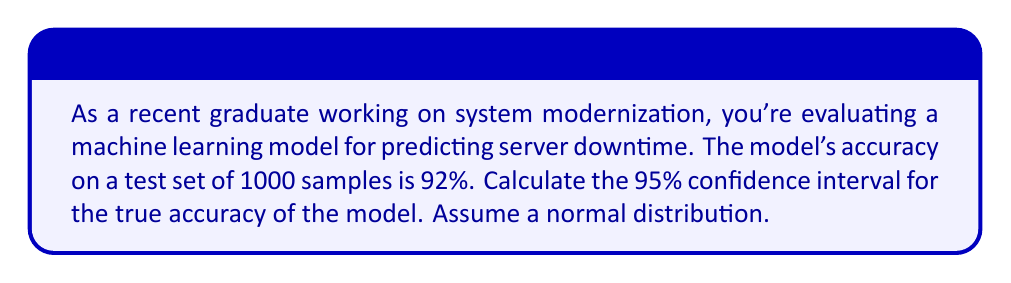Provide a solution to this math problem. Let's approach this step-by-step:

1) First, we need to identify the key components:
   - Sample size (n) = 1000
   - Sample proportion (p) = 0.92 (92% accuracy)
   - Confidence level = 95% (z-score = 1.96)

2) The formula for the confidence interval of a proportion is:

   $$ CI = p \pm z \sqrt{\frac{p(1-p)}{n}} $$

3) Let's calculate the standard error:

   $$ SE = \sqrt{\frac{p(1-p)}{n}} = \sqrt{\frac{0.92(1-0.92)}{1000}} = \sqrt{\frac{0.0736}{1000}} = 0.00857 $$

4) Now, we can calculate the margin of error:

   $$ ME = z \cdot SE = 1.96 \cdot 0.00857 = 0.0168 $$

5) Finally, we can calculate the confidence interval:

   Lower bound: $0.92 - 0.0168 = 0.9032$
   Upper bound: $0.92 + 0.0168 = 0.9368$

6) Converting to percentages:

   The 95% confidence interval is (90.32%, 93.68%)

This means we can be 95% confident that the true accuracy of the model lies between 90.32% and 93.68%.
Answer: (90.32%, 93.68%) 